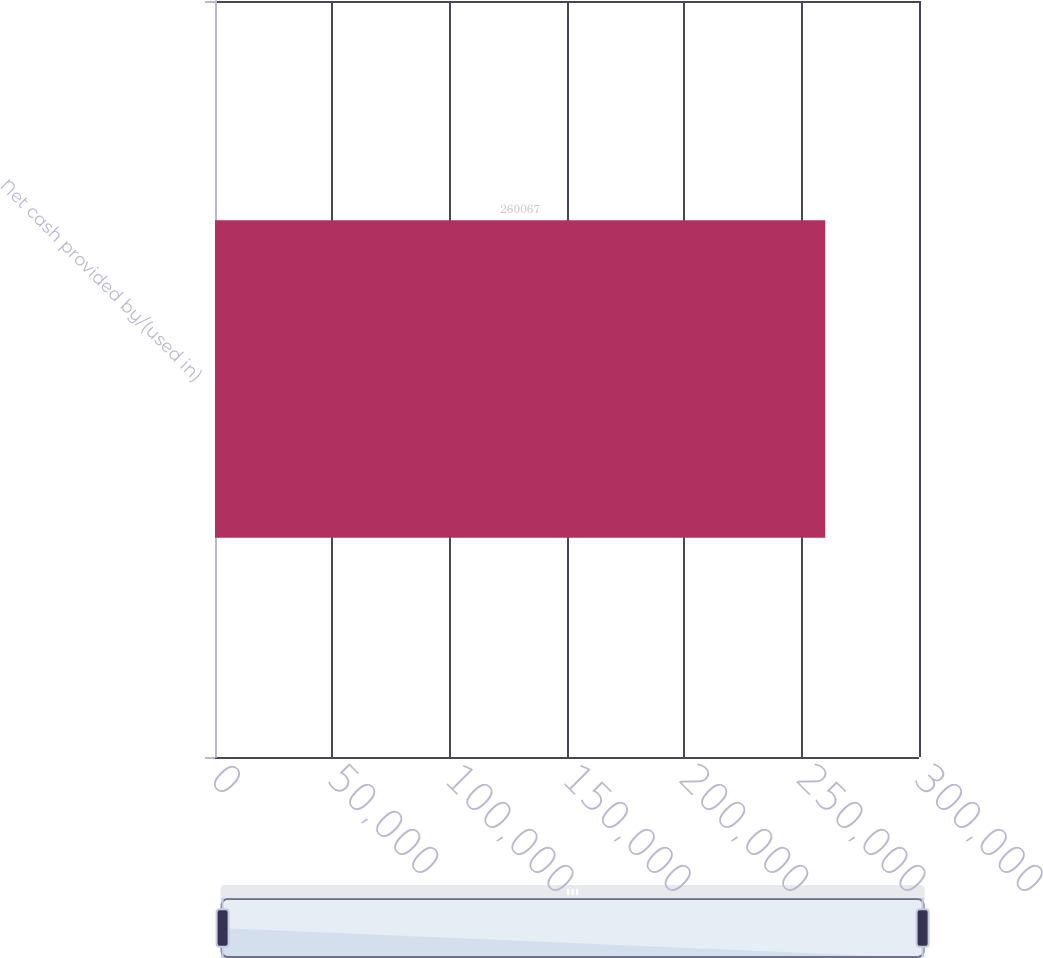Convert chart. <chart><loc_0><loc_0><loc_500><loc_500><bar_chart><fcel>Net cash provided by/(used in)<nl><fcel>260067<nl></chart> 